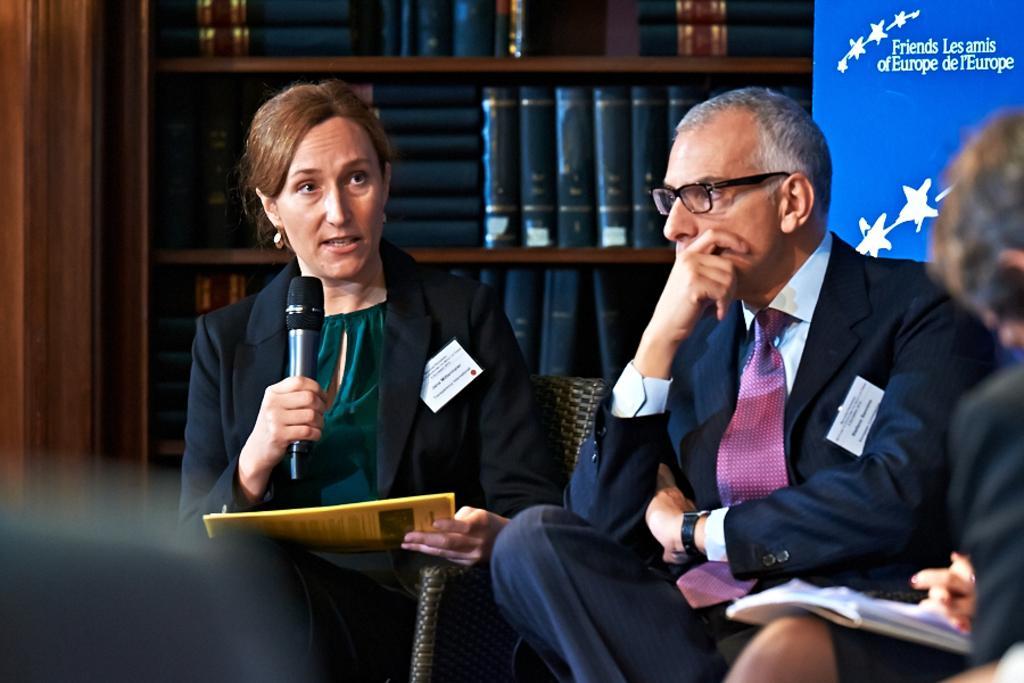How would you summarize this image in a sentence or two? In this picture there is a woman who is wearing blazer and green dress. She is holding a file and mic. She is sitting on the chair. Beside her there is a man who is wearing spectacle, watch and trousers. On the right I can see another woman who is holding the book and papers. In the back I can see many black color books which are kept on the wooden shelves. In the top right corner it might be a projector screen or banner. 